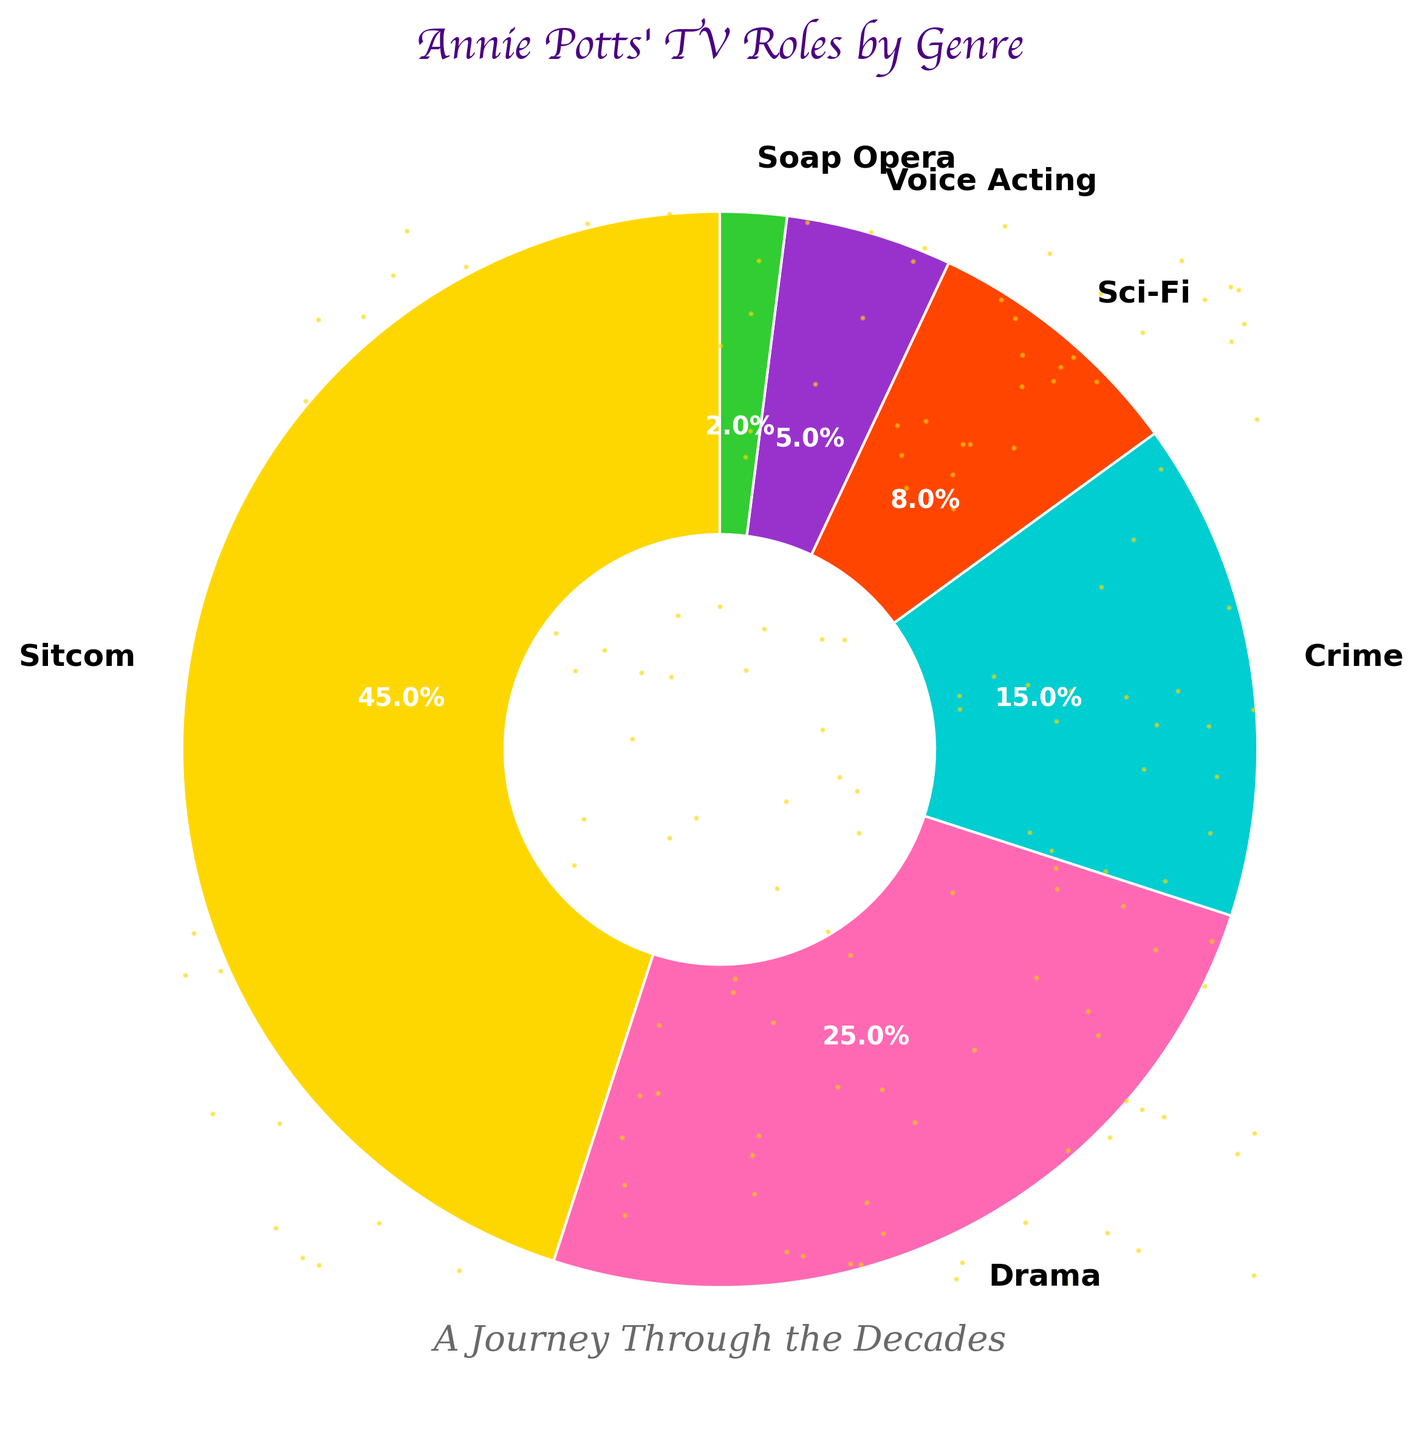What's the most common genre Annie Potts has acted in according to the pie chart? The pie chart shows the largest wedge representing the genre, which is "Sitcom" with 45%. This is the most common genre.
Answer: Sitcom Which two genres combined account for more than half of Annie Potts' TV roles? Adding the percentages of "Sitcom" (45%) and "Drama" (25%) equals 70%, which is more than half (50%). Hence, the two genres are "Sitcom" and "Drama".
Answer: Sitcom and Drama How much larger is the percentage of Sitcom roles compared to Crime roles? The percentage of Sitcom roles is 45% and that of Crime roles is 15%. Subtracting these values gives 45% - 15% = 30%.
Answer: 30% Which genre has the fewest roles and what percentage does it represent? The smallest wedge in the pie chart is "Soap Opera," which represents 2%.
Answer: Soap Opera, 2% Is the percentage of Drama roles greater than the sum of Sci-Fi and Voice Acting roles? The percentage of Drama roles is 25%. The combined percentage of Sci-Fi (8%) and Voice Acting (5%) is 13%. Since 25% is greater than 13%, the answer is yes.
Answer: Yes What is the second most common genre in Annie Potts' TV roles according to the chart? The second largest wedge in the pie chart represents the genre "Drama" with a percentage of 25%, making it the second most common genre.
Answer: Drama What percentage of Annie Potts' roles are in genres other than Sitcom and Drama? The combined percentage of Sitcom and Drama is 45% + 25% = 70%. Subtracting this from 100% gives 100% - 70% = 30%.
Answer: 30% Compare the percentage of Sci-Fi roles to that of Voice Acting roles. Which one is higher and by how much? The percentage of Sci-Fi roles is 8%, and that of Voice Acting roles is 5%. The difference is 8% - 5% = 3%, and Sci-Fi is higher by 3%.
Answer: Sci-Fi, 3% What is the total percentage of Annie Potts' acting roles in genres classified as drama and crime? Adding the percentages for Drama (25%) and Crime (15%) gives 25% + 15% = 40%.
Answer: 40% If you group Sci-Fi and Soap Opera together, what percentage of Annie Potts' roles do they cover? Adding the percentages of Sci-Fi (8%) and Soap Opera (2%) gives 8% + 2% = 10%.
Answer: 10% 